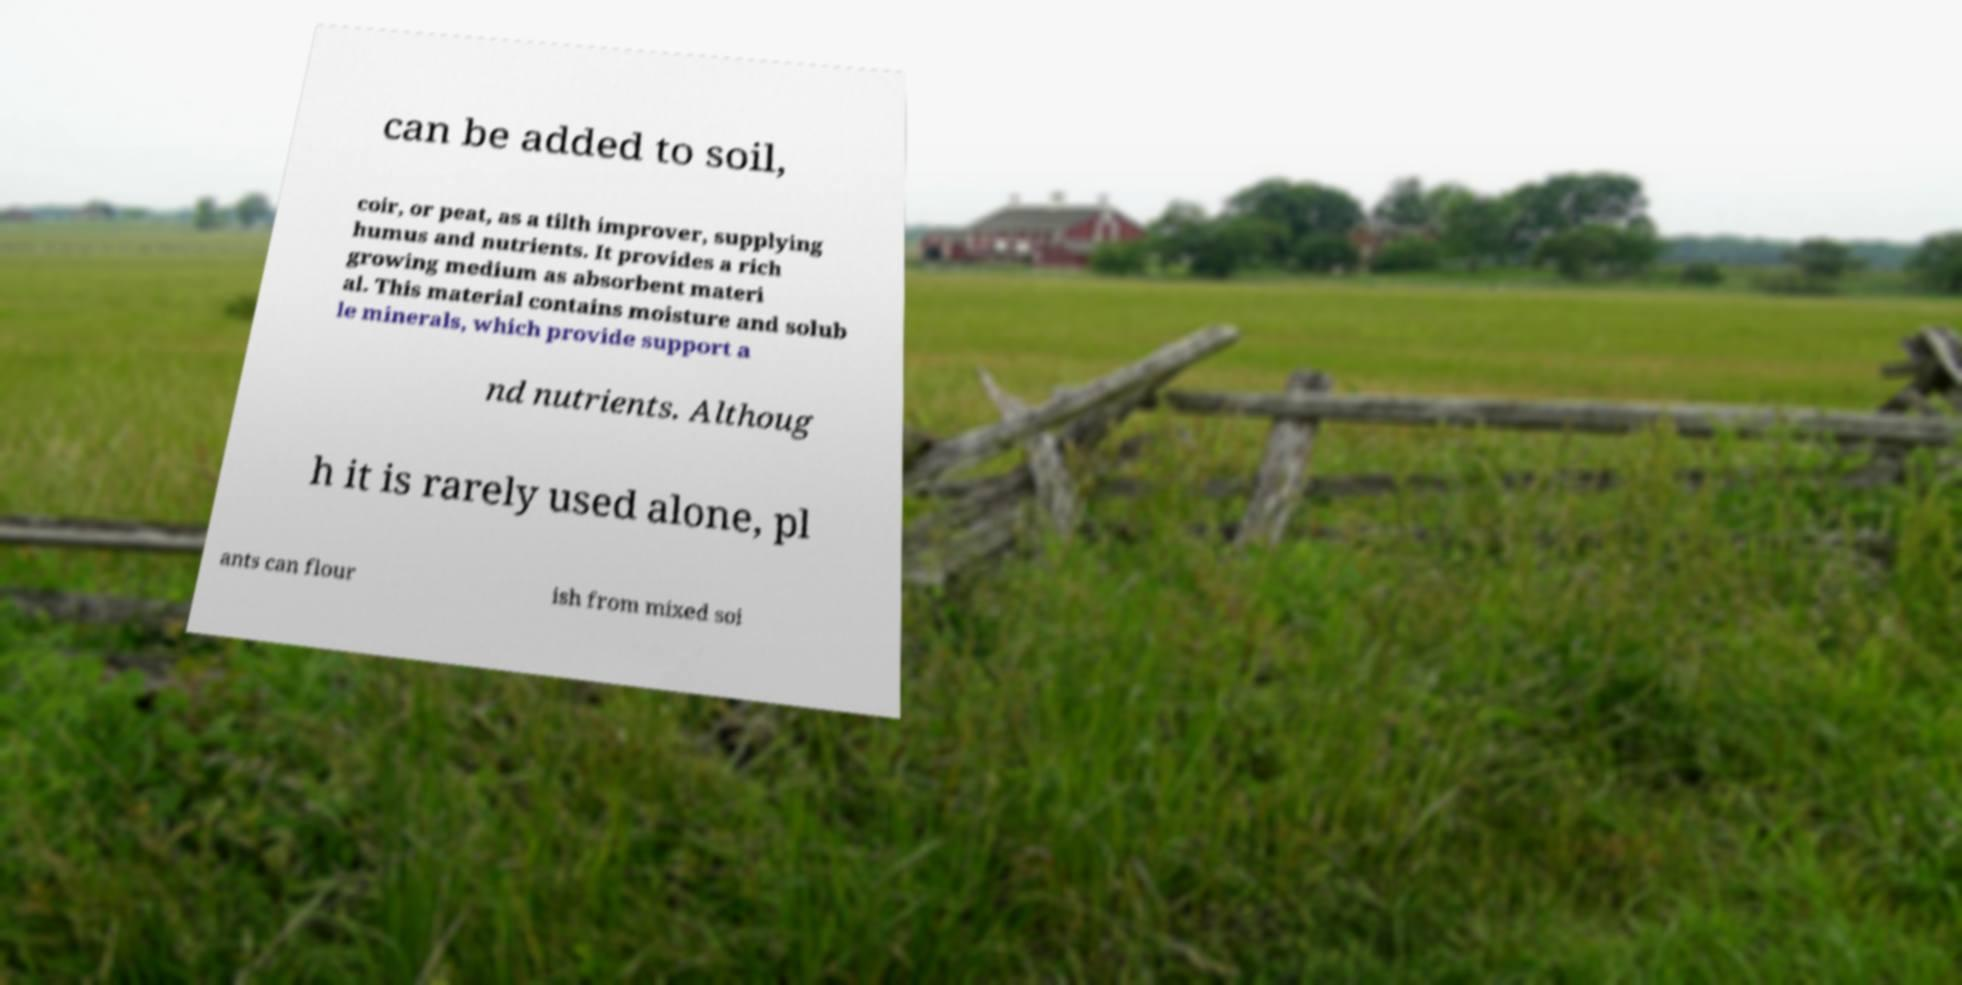Please identify and transcribe the text found in this image. can be added to soil, coir, or peat, as a tilth improver, supplying humus and nutrients. It provides a rich growing medium as absorbent materi al. This material contains moisture and solub le minerals, which provide support a nd nutrients. Althoug h it is rarely used alone, pl ants can flour ish from mixed soi 